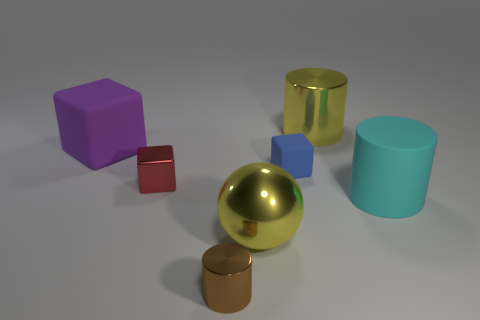Subtract all yellow cubes. Subtract all brown cylinders. How many cubes are left? 3 Add 2 tiny things. How many objects exist? 9 Subtract all balls. How many objects are left? 6 Add 3 tiny brown metal cylinders. How many tiny brown metal cylinders exist? 4 Subtract 0 purple cylinders. How many objects are left? 7 Subtract all cyan objects. Subtract all yellow cubes. How many objects are left? 6 Add 3 blue matte objects. How many blue matte objects are left? 4 